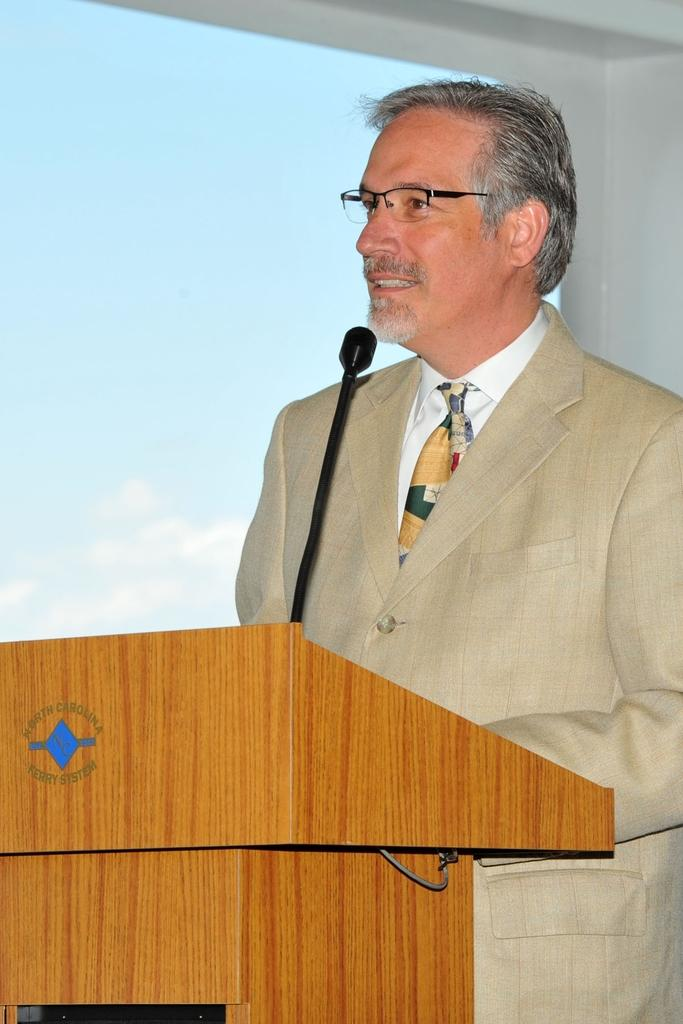What is the main subject of the image? There is a person standing in the image. How is the person positioned in the image? The person is standing on the bias. What can be seen in the background of the image? There is a sky and a wall visible in the background of the image. Can you tell me how many worms are crawling on the person's shoes in the image? There are no worms present in the image, so it is not possible to determine their number. 